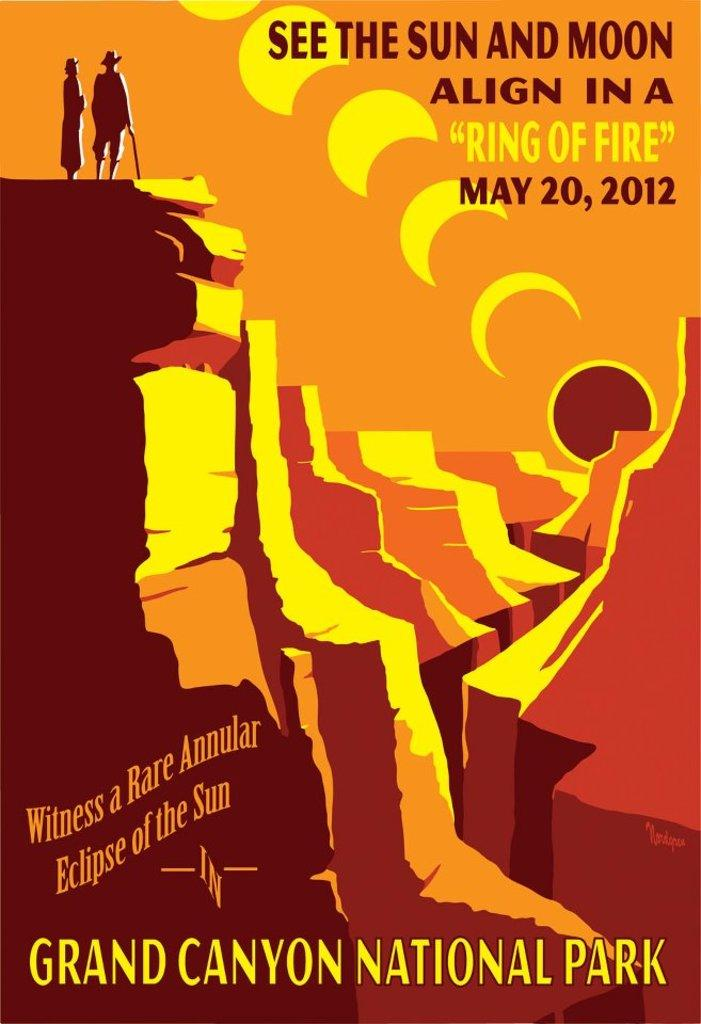What is present on the poster in the image? The poster contains text and an image. Can you describe the image on the poster? Unfortunately, the specific image on the poster cannot be described without more information. What type of information is conveyed through the text on the poster? The content of the text on the poster cannot be determined without more information. How many holes are visible in the image? There are no holes visible in the image. What type of range is depicted in the image? There is no range present in the image. 